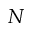<formula> <loc_0><loc_0><loc_500><loc_500>N</formula> 